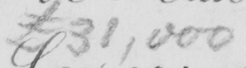Can you read and transcribe this handwriting? £31,000 